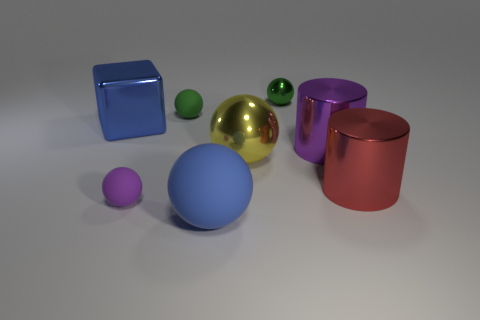Subtract 1 spheres. How many spheres are left? 4 Add 2 small yellow rubber blocks. How many objects exist? 10 Subtract all red balls. Subtract all cyan cylinders. How many balls are left? 5 Subtract all blocks. How many objects are left? 7 Subtract all purple shiny cylinders. Subtract all large gray matte spheres. How many objects are left? 7 Add 5 metal things. How many metal things are left? 10 Add 5 small cyan matte things. How many small cyan matte things exist? 5 Subtract 0 brown spheres. How many objects are left? 8 